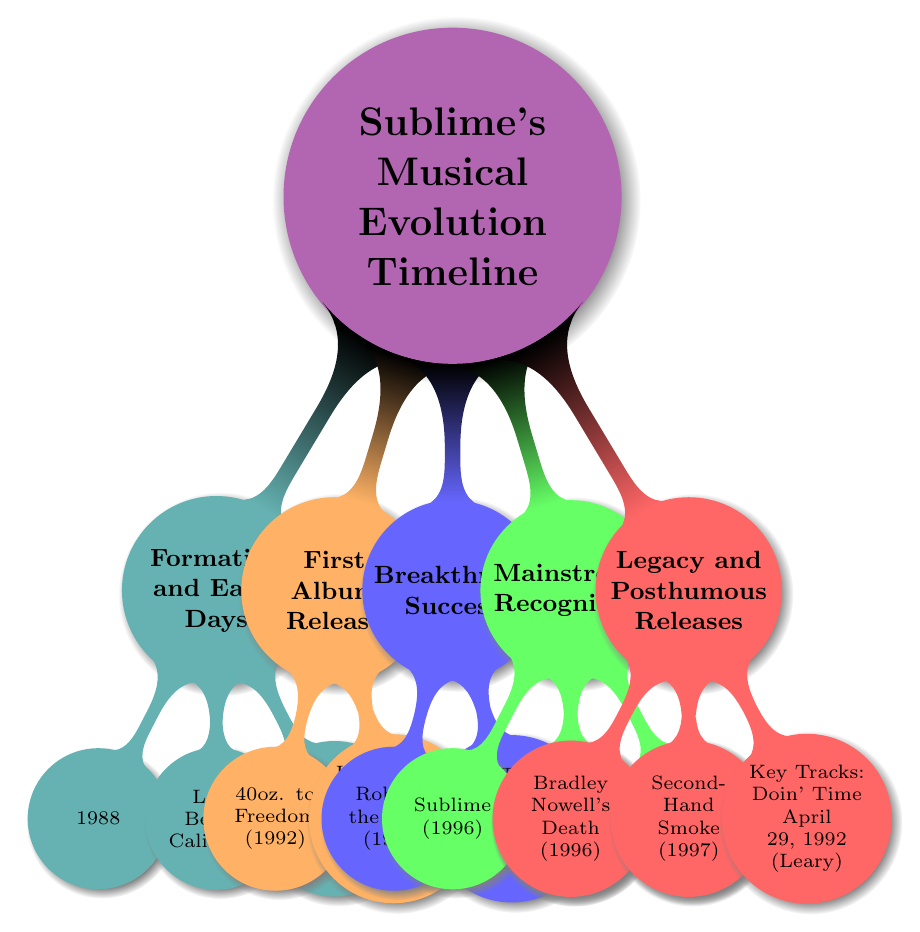What year was Sublime's first album released? The diagram indicates that Sublime's first album, "40oz. to Freedom," was released in 1992.
Answer: 1992 Who were the founding members of Sublime? The diagram lists Bradley Nowell, Eric Wilson, and Bud Gaugh as the founding members in the "Formation and Early Days" section, which outlines the early history of the band.
Answer: Bradley Nowell, Eric Wilson, Bud Gaugh What was the impact of the album "Sublime"? According to the diagram, the album "Sublime" had a "Multi-Platinum Certification," indicating significant commercial success and recognition.
Answer: Multi-Platinum Certification Which album featured the key track "Doin' Time"? The diagram shows that the key track "Doin' Time" is from the posthumous album "Second-Hand Smoke," released in 1997.
Answer: Second-Hand Smoke What year did Bradley Nowell pass away? The diagram states that Bradley Nowell passed away in 1996, a significant event in the band's history mentioned under "Legacy and Posthumous Releases."
Answer: 1996 How many albums were released after Bradley Nowell's death? From the diagram, only one album, "Second-Hand Smoke" (1997), is noted as a posthumous album following Bradley Nowell's death.
Answer: 1 Which album was released in 1994? The diagram specifies that "Robbin' the Hood" was the album released in 1994, contributing to the band's breakthrough success.
Answer: Robbin' the Hood What are the key tracks from the album "Sublime"? Under the "Mainstream Recognition" section in the diagram, the key tracks listed for the album "Sublime" are "What I Got," "Santeria," and "Wrong Way."
Answer: What I Got, Santeria, Wrong Way 